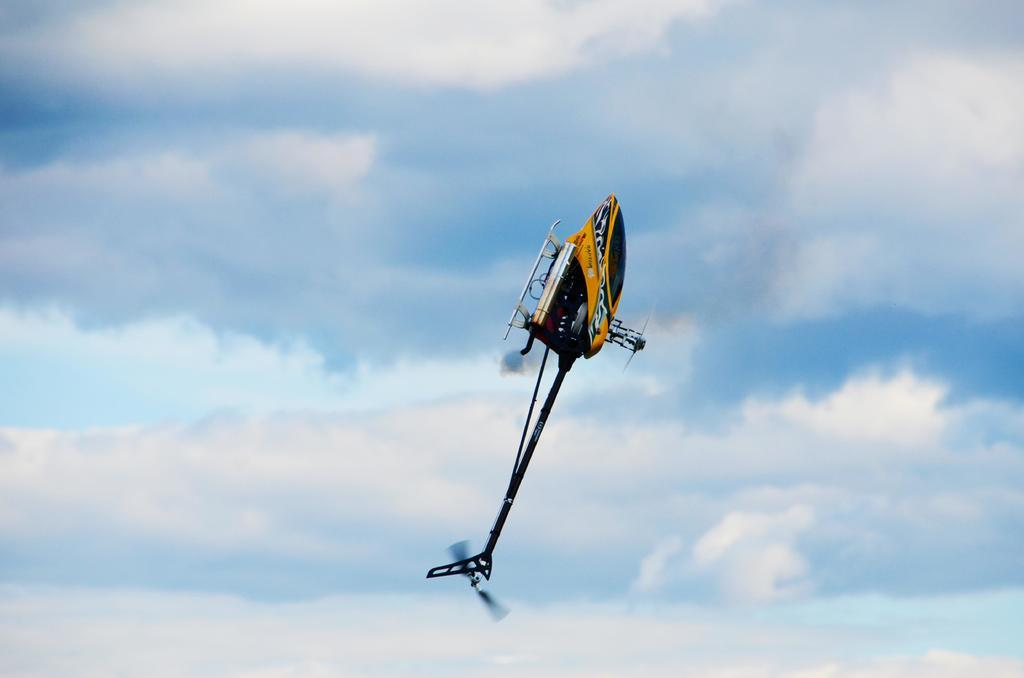What is the main subject of the image? The main subject of the image is an airplane. Can you describe the location of the airplane in the image? The airplane is in the air in the image. What can be seen in the background of the image? There is sky visible in the background of the image. What is the condition of the sky in the image? Clouds are present in the sky in the image. How many eggs are visible in the image? There are no eggs present in the image. Is there a cave visible in the image? There is no cave present in the image. 